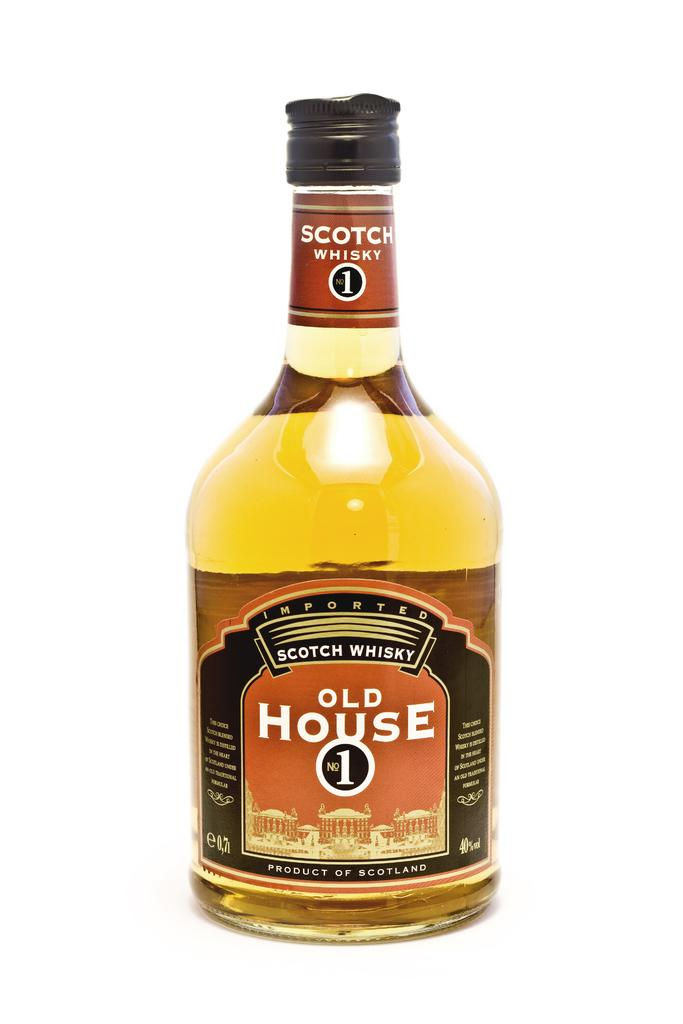<image>
Relay a brief, clear account of the picture shown. A bottle of Old House 1 Scotch Whisky witha brown and red label. 